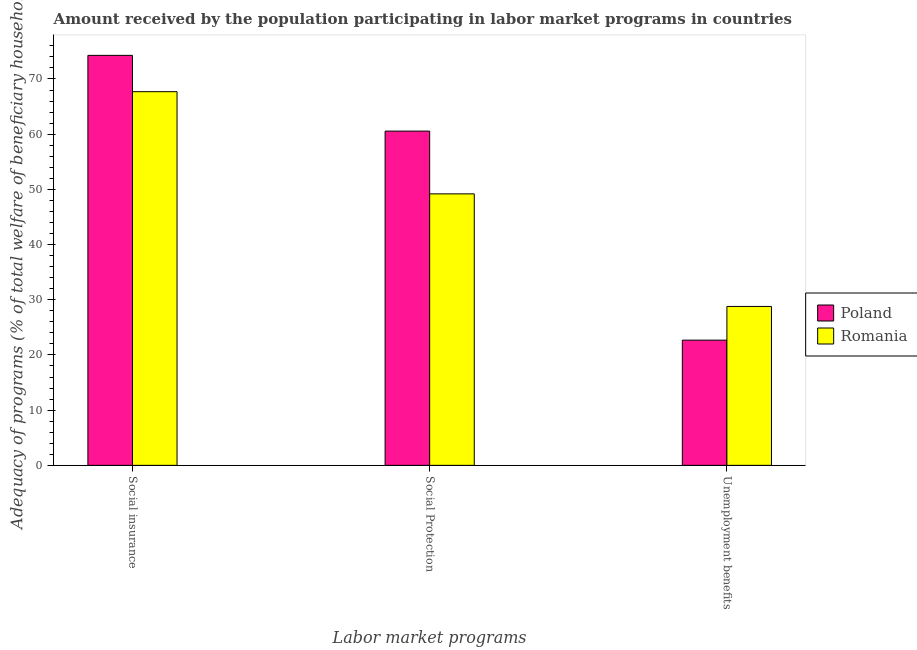Are the number of bars on each tick of the X-axis equal?
Provide a short and direct response. Yes. How many bars are there on the 1st tick from the right?
Provide a succinct answer. 2. What is the label of the 1st group of bars from the left?
Provide a short and direct response. Social insurance. What is the amount received by the population participating in social protection programs in Romania?
Give a very brief answer. 49.18. Across all countries, what is the maximum amount received by the population participating in social insurance programs?
Your response must be concise. 74.28. Across all countries, what is the minimum amount received by the population participating in unemployment benefits programs?
Your answer should be very brief. 22.68. In which country was the amount received by the population participating in unemployment benefits programs maximum?
Ensure brevity in your answer.  Romania. In which country was the amount received by the population participating in social insurance programs minimum?
Ensure brevity in your answer.  Romania. What is the total amount received by the population participating in social protection programs in the graph?
Provide a short and direct response. 109.74. What is the difference between the amount received by the population participating in social insurance programs in Romania and that in Poland?
Your answer should be very brief. -6.58. What is the difference between the amount received by the population participating in social protection programs in Romania and the amount received by the population participating in social insurance programs in Poland?
Your answer should be very brief. -25.09. What is the average amount received by the population participating in social protection programs per country?
Provide a short and direct response. 54.87. What is the difference between the amount received by the population participating in social insurance programs and amount received by the population participating in social protection programs in Romania?
Your answer should be compact. 18.51. What is the ratio of the amount received by the population participating in unemployment benefits programs in Romania to that in Poland?
Your answer should be very brief. 1.27. What is the difference between the highest and the second highest amount received by the population participating in social insurance programs?
Provide a short and direct response. 6.58. What is the difference between the highest and the lowest amount received by the population participating in social insurance programs?
Provide a succinct answer. 6.58. Is the sum of the amount received by the population participating in social protection programs in Romania and Poland greater than the maximum amount received by the population participating in social insurance programs across all countries?
Ensure brevity in your answer.  Yes. What does the 2nd bar from the left in Unemployment benefits represents?
Offer a very short reply. Romania. What does the 1st bar from the right in Social insurance represents?
Your response must be concise. Romania. Is it the case that in every country, the sum of the amount received by the population participating in social insurance programs and amount received by the population participating in social protection programs is greater than the amount received by the population participating in unemployment benefits programs?
Your response must be concise. Yes. How many countries are there in the graph?
Your answer should be very brief. 2. What is the difference between two consecutive major ticks on the Y-axis?
Offer a very short reply. 10. Does the graph contain any zero values?
Keep it short and to the point. No. Does the graph contain grids?
Keep it short and to the point. No. What is the title of the graph?
Your response must be concise. Amount received by the population participating in labor market programs in countries. Does "Lebanon" appear as one of the legend labels in the graph?
Provide a succinct answer. No. What is the label or title of the X-axis?
Make the answer very short. Labor market programs. What is the label or title of the Y-axis?
Ensure brevity in your answer.  Adequacy of programs (% of total welfare of beneficiary households). What is the Adequacy of programs (% of total welfare of beneficiary households) in Poland in Social insurance?
Offer a terse response. 74.28. What is the Adequacy of programs (% of total welfare of beneficiary households) in Romania in Social insurance?
Ensure brevity in your answer.  67.7. What is the Adequacy of programs (% of total welfare of beneficiary households) in Poland in Social Protection?
Provide a short and direct response. 60.56. What is the Adequacy of programs (% of total welfare of beneficiary households) of Romania in Social Protection?
Your response must be concise. 49.18. What is the Adequacy of programs (% of total welfare of beneficiary households) in Poland in Unemployment benefits?
Keep it short and to the point. 22.68. What is the Adequacy of programs (% of total welfare of beneficiary households) in Romania in Unemployment benefits?
Provide a short and direct response. 28.79. Across all Labor market programs, what is the maximum Adequacy of programs (% of total welfare of beneficiary households) of Poland?
Your response must be concise. 74.28. Across all Labor market programs, what is the maximum Adequacy of programs (% of total welfare of beneficiary households) in Romania?
Ensure brevity in your answer.  67.7. Across all Labor market programs, what is the minimum Adequacy of programs (% of total welfare of beneficiary households) of Poland?
Your answer should be very brief. 22.68. Across all Labor market programs, what is the minimum Adequacy of programs (% of total welfare of beneficiary households) in Romania?
Provide a succinct answer. 28.79. What is the total Adequacy of programs (% of total welfare of beneficiary households) of Poland in the graph?
Offer a very short reply. 157.51. What is the total Adequacy of programs (% of total welfare of beneficiary households) in Romania in the graph?
Offer a very short reply. 145.67. What is the difference between the Adequacy of programs (% of total welfare of beneficiary households) of Poland in Social insurance and that in Social Protection?
Your answer should be very brief. 13.72. What is the difference between the Adequacy of programs (% of total welfare of beneficiary households) of Romania in Social insurance and that in Social Protection?
Keep it short and to the point. 18.51. What is the difference between the Adequacy of programs (% of total welfare of beneficiary households) of Poland in Social insurance and that in Unemployment benefits?
Provide a short and direct response. 51.59. What is the difference between the Adequacy of programs (% of total welfare of beneficiary households) in Romania in Social insurance and that in Unemployment benefits?
Ensure brevity in your answer.  38.91. What is the difference between the Adequacy of programs (% of total welfare of beneficiary households) of Poland in Social Protection and that in Unemployment benefits?
Provide a succinct answer. 37.87. What is the difference between the Adequacy of programs (% of total welfare of beneficiary households) in Romania in Social Protection and that in Unemployment benefits?
Your response must be concise. 20.4. What is the difference between the Adequacy of programs (% of total welfare of beneficiary households) of Poland in Social insurance and the Adequacy of programs (% of total welfare of beneficiary households) of Romania in Social Protection?
Make the answer very short. 25.09. What is the difference between the Adequacy of programs (% of total welfare of beneficiary households) of Poland in Social insurance and the Adequacy of programs (% of total welfare of beneficiary households) of Romania in Unemployment benefits?
Provide a short and direct response. 45.49. What is the difference between the Adequacy of programs (% of total welfare of beneficiary households) of Poland in Social Protection and the Adequacy of programs (% of total welfare of beneficiary households) of Romania in Unemployment benefits?
Give a very brief answer. 31.77. What is the average Adequacy of programs (% of total welfare of beneficiary households) of Poland per Labor market programs?
Provide a short and direct response. 52.5. What is the average Adequacy of programs (% of total welfare of beneficiary households) of Romania per Labor market programs?
Make the answer very short. 48.56. What is the difference between the Adequacy of programs (% of total welfare of beneficiary households) of Poland and Adequacy of programs (% of total welfare of beneficiary households) of Romania in Social insurance?
Provide a succinct answer. 6.58. What is the difference between the Adequacy of programs (% of total welfare of beneficiary households) in Poland and Adequacy of programs (% of total welfare of beneficiary households) in Romania in Social Protection?
Offer a very short reply. 11.37. What is the difference between the Adequacy of programs (% of total welfare of beneficiary households) of Poland and Adequacy of programs (% of total welfare of beneficiary households) of Romania in Unemployment benefits?
Keep it short and to the point. -6.11. What is the ratio of the Adequacy of programs (% of total welfare of beneficiary households) of Poland in Social insurance to that in Social Protection?
Your answer should be compact. 1.23. What is the ratio of the Adequacy of programs (% of total welfare of beneficiary households) in Romania in Social insurance to that in Social Protection?
Make the answer very short. 1.38. What is the ratio of the Adequacy of programs (% of total welfare of beneficiary households) of Poland in Social insurance to that in Unemployment benefits?
Provide a succinct answer. 3.27. What is the ratio of the Adequacy of programs (% of total welfare of beneficiary households) of Romania in Social insurance to that in Unemployment benefits?
Your response must be concise. 2.35. What is the ratio of the Adequacy of programs (% of total welfare of beneficiary households) of Poland in Social Protection to that in Unemployment benefits?
Give a very brief answer. 2.67. What is the ratio of the Adequacy of programs (% of total welfare of beneficiary households) in Romania in Social Protection to that in Unemployment benefits?
Provide a short and direct response. 1.71. What is the difference between the highest and the second highest Adequacy of programs (% of total welfare of beneficiary households) in Poland?
Provide a short and direct response. 13.72. What is the difference between the highest and the second highest Adequacy of programs (% of total welfare of beneficiary households) of Romania?
Make the answer very short. 18.51. What is the difference between the highest and the lowest Adequacy of programs (% of total welfare of beneficiary households) of Poland?
Provide a succinct answer. 51.59. What is the difference between the highest and the lowest Adequacy of programs (% of total welfare of beneficiary households) in Romania?
Offer a terse response. 38.91. 